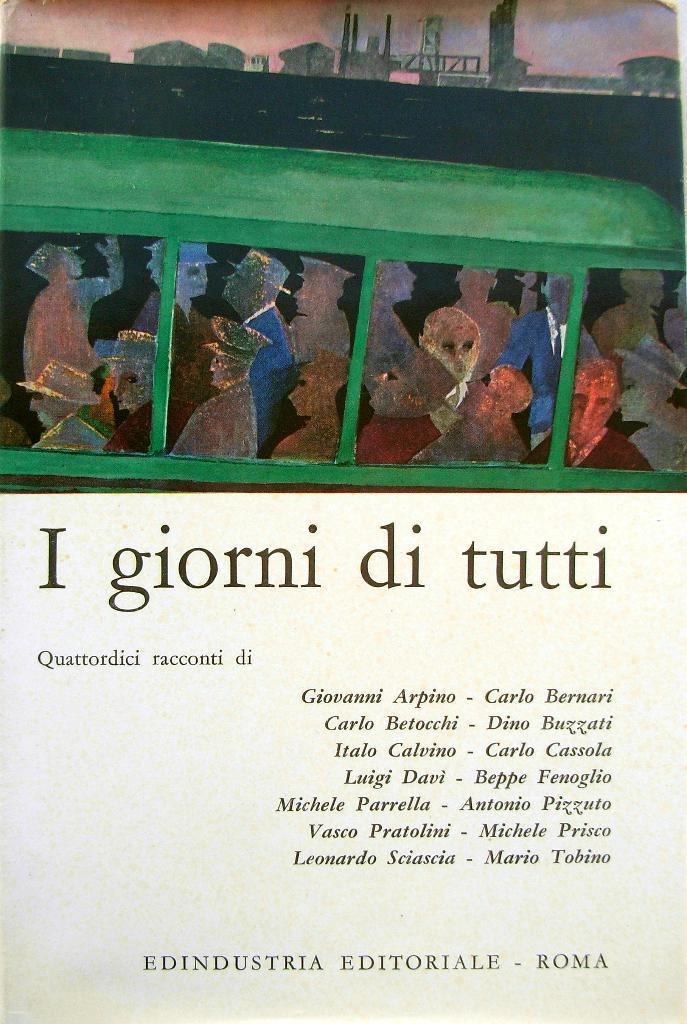How many people are in the image? There is a group of people in the image, but the exact number is not specified. What else can be seen in the image besides the people? There is text visible in the image. What thrilling word can be seen in the text of the image? There is no information about the content of the text in the image, so it is not possible to determine if any words are thrilling. 